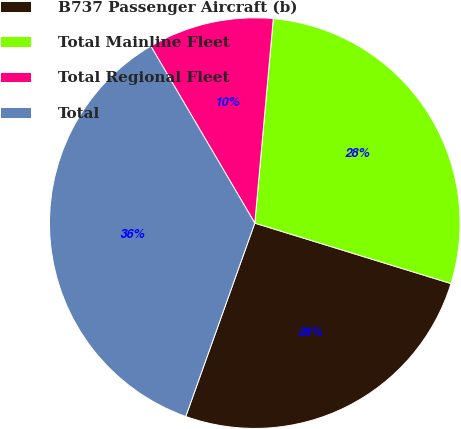Convert chart. <chart><loc_0><loc_0><loc_500><loc_500><pie_chart><fcel>B737 Passenger Aircraft (b)<fcel>Total Mainline Fleet<fcel>Total Regional Fleet<fcel>Total<nl><fcel>25.7%<fcel>28.32%<fcel>9.89%<fcel>36.09%<nl></chart> 